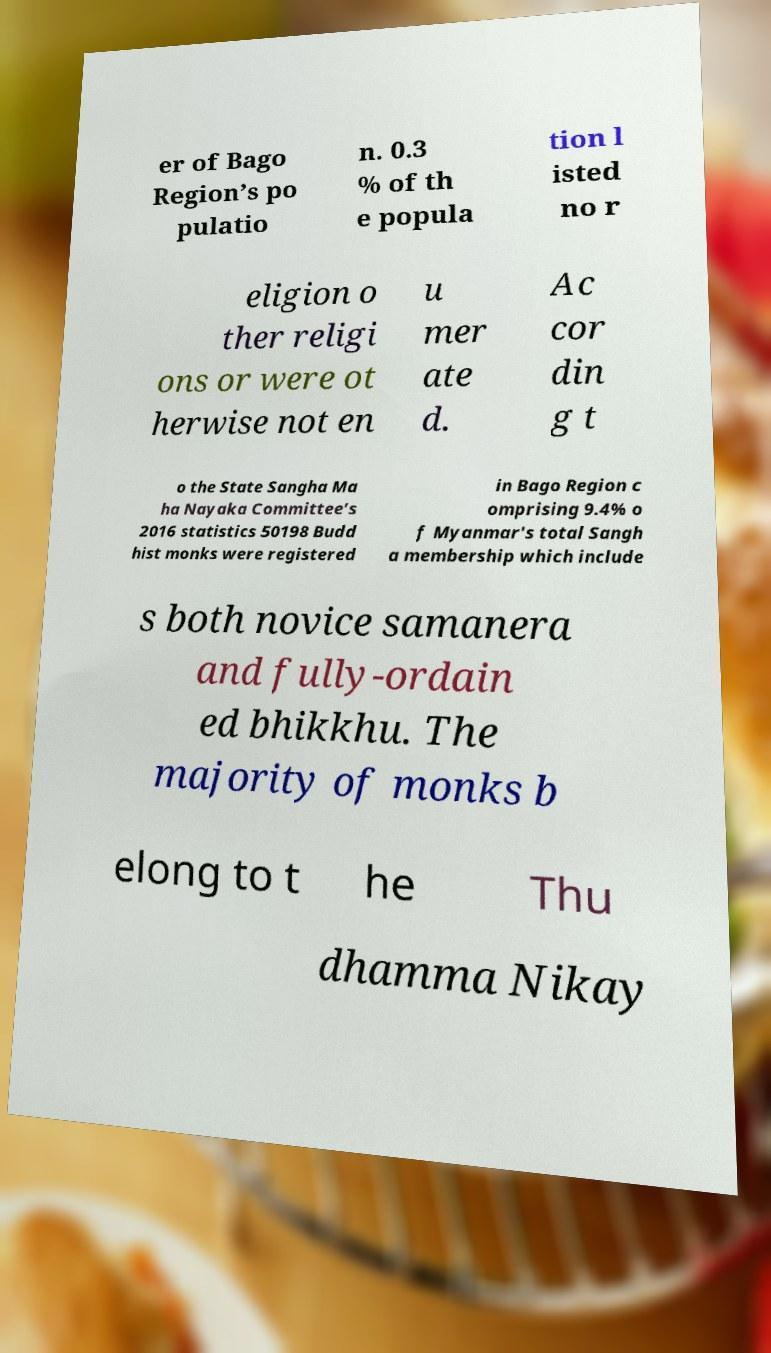Please read and relay the text visible in this image. What does it say? er of Bago Region’s po pulatio n. 0.3 % of th e popula tion l isted no r eligion o ther religi ons or were ot herwise not en u mer ate d. Ac cor din g t o the State Sangha Ma ha Nayaka Committee’s 2016 statistics 50198 Budd hist monks were registered in Bago Region c omprising 9.4% o f Myanmar's total Sangh a membership which include s both novice samanera and fully-ordain ed bhikkhu. The majority of monks b elong to t he Thu dhamma Nikay 